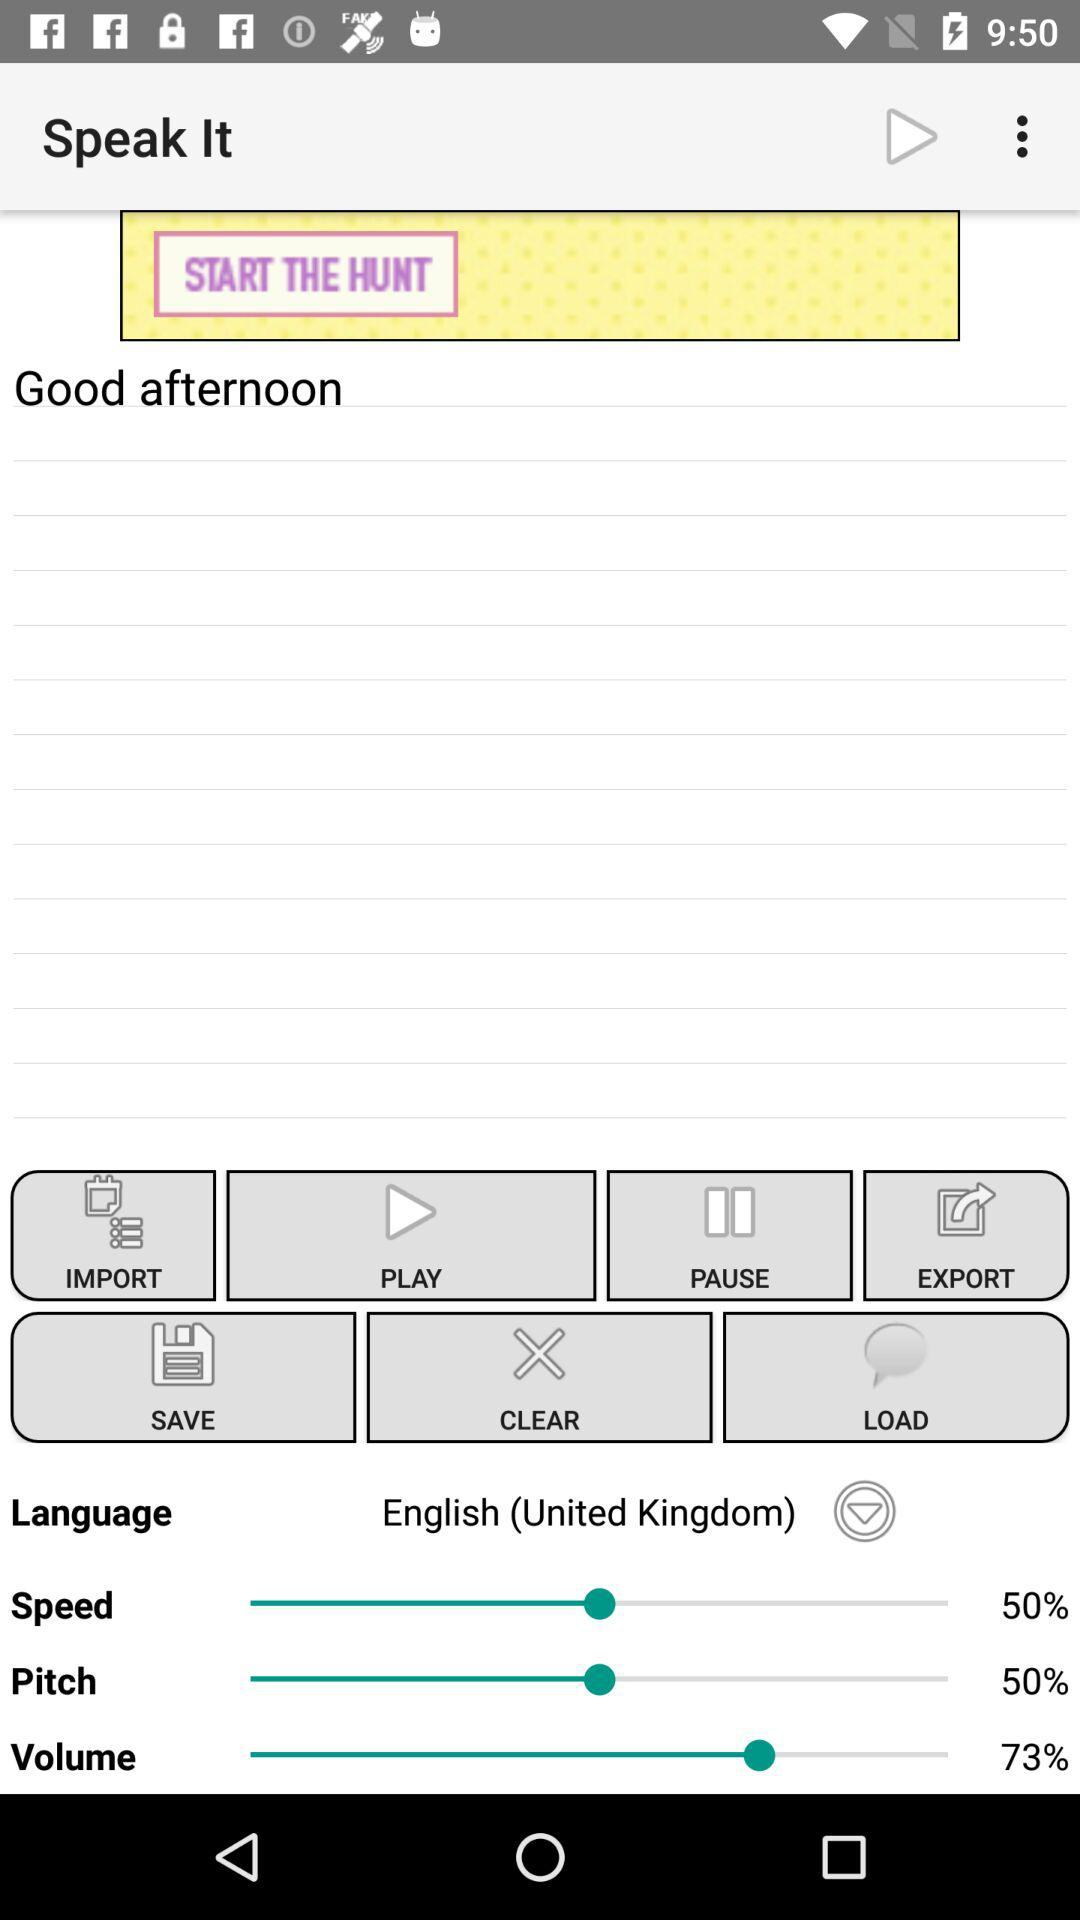For which option is 73% set? 73% is set for the "Volume" option. 